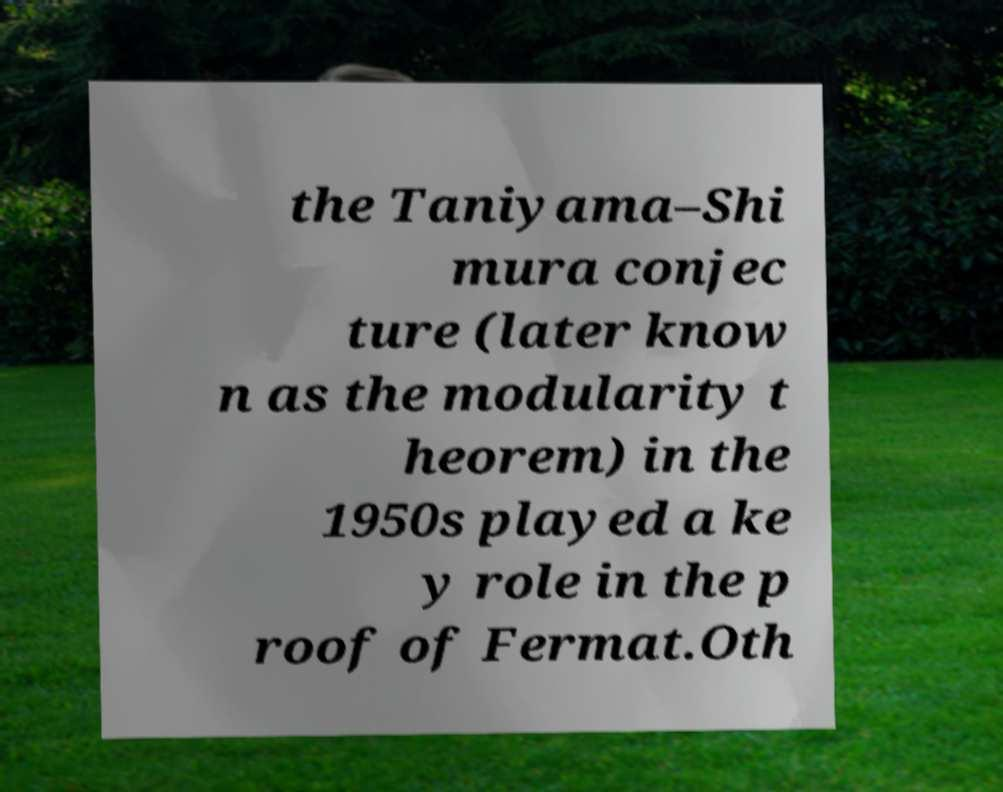For documentation purposes, I need the text within this image transcribed. Could you provide that? the Taniyama–Shi mura conjec ture (later know n as the modularity t heorem) in the 1950s played a ke y role in the p roof of Fermat.Oth 